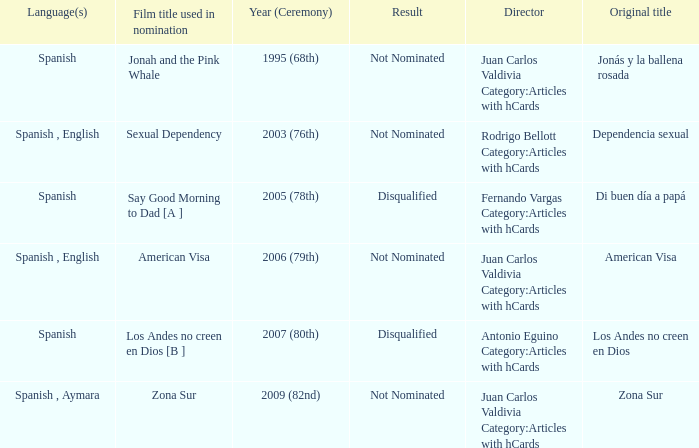What was Zona Sur's result after being considered for nomination? Not Nominated. Help me parse the entirety of this table. {'header': ['Language(s)', 'Film title used in nomination', 'Year (Ceremony)', 'Result', 'Director', 'Original title'], 'rows': [['Spanish', 'Jonah and the Pink Whale', '1995 (68th)', 'Not Nominated', 'Juan Carlos Valdivia Category:Articles with hCards', 'Jonás y la ballena rosada'], ['Spanish , English', 'Sexual Dependency', '2003 (76th)', 'Not Nominated', 'Rodrigo Bellott Category:Articles with hCards', 'Dependencia sexual'], ['Spanish', 'Say Good Morning to Dad [A ]', '2005 (78th)', 'Disqualified', 'Fernando Vargas Category:Articles with hCards', 'Di buen día a papá'], ['Spanish , English', 'American Visa', '2006 (79th)', 'Not Nominated', 'Juan Carlos Valdivia Category:Articles with hCards', 'American Visa'], ['Spanish', 'Los Andes no creen en Dios [B ]', '2007 (80th)', 'Disqualified', 'Antonio Eguino Category:Articles with hCards', 'Los Andes no creen en Dios'], ['Spanish , Aymara', 'Zona Sur', '2009 (82nd)', 'Not Nominated', 'Juan Carlos Valdivia Category:Articles with hCards', 'Zona Sur']]} 